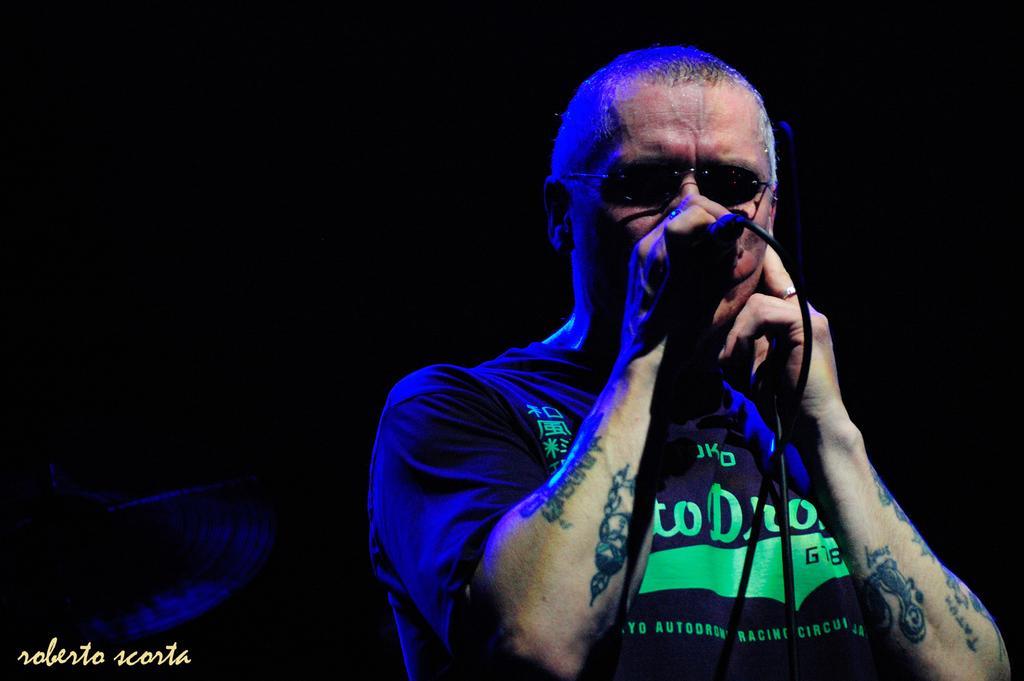In one or two sentences, can you explain what this image depicts? In this image we can see a person holding a mic and a dark background. 